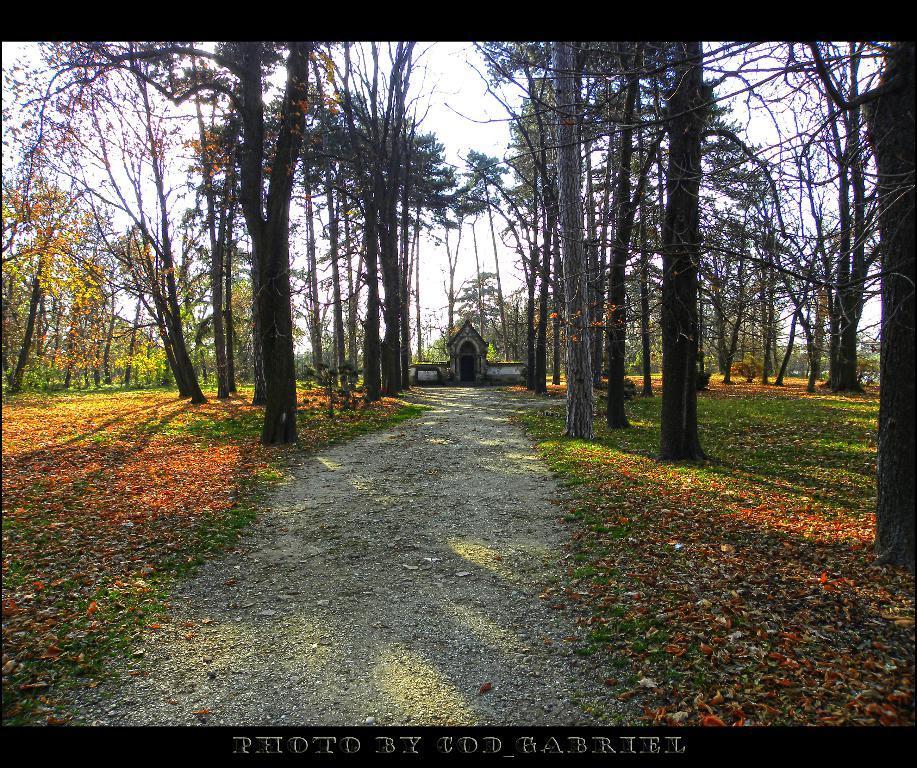In one or two sentences, can you explain what this image depicts? These are the trees with branches and leaves. This looks like a house. Here is a pathway. I can see the leaves lying on the grass. This is the watermark on the image. 